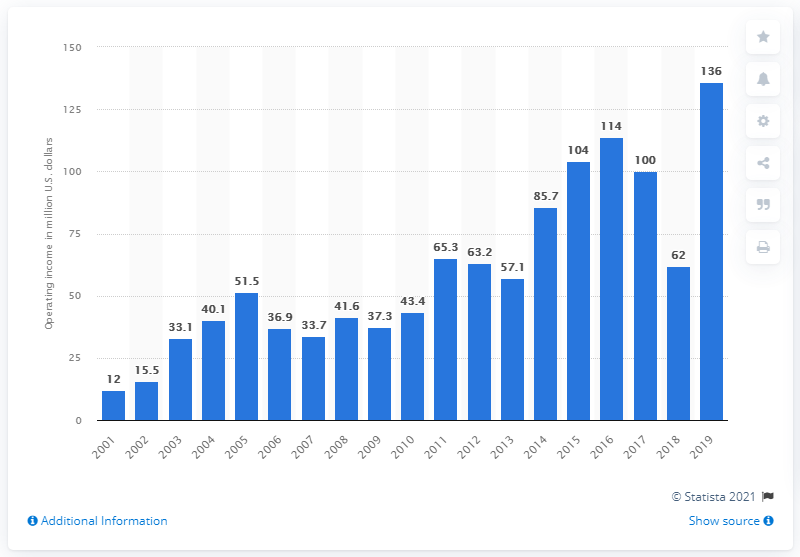Indicate a few pertinent items in this graphic. The Chicago Bears had an operating income of $136 million in the 2019 season. 